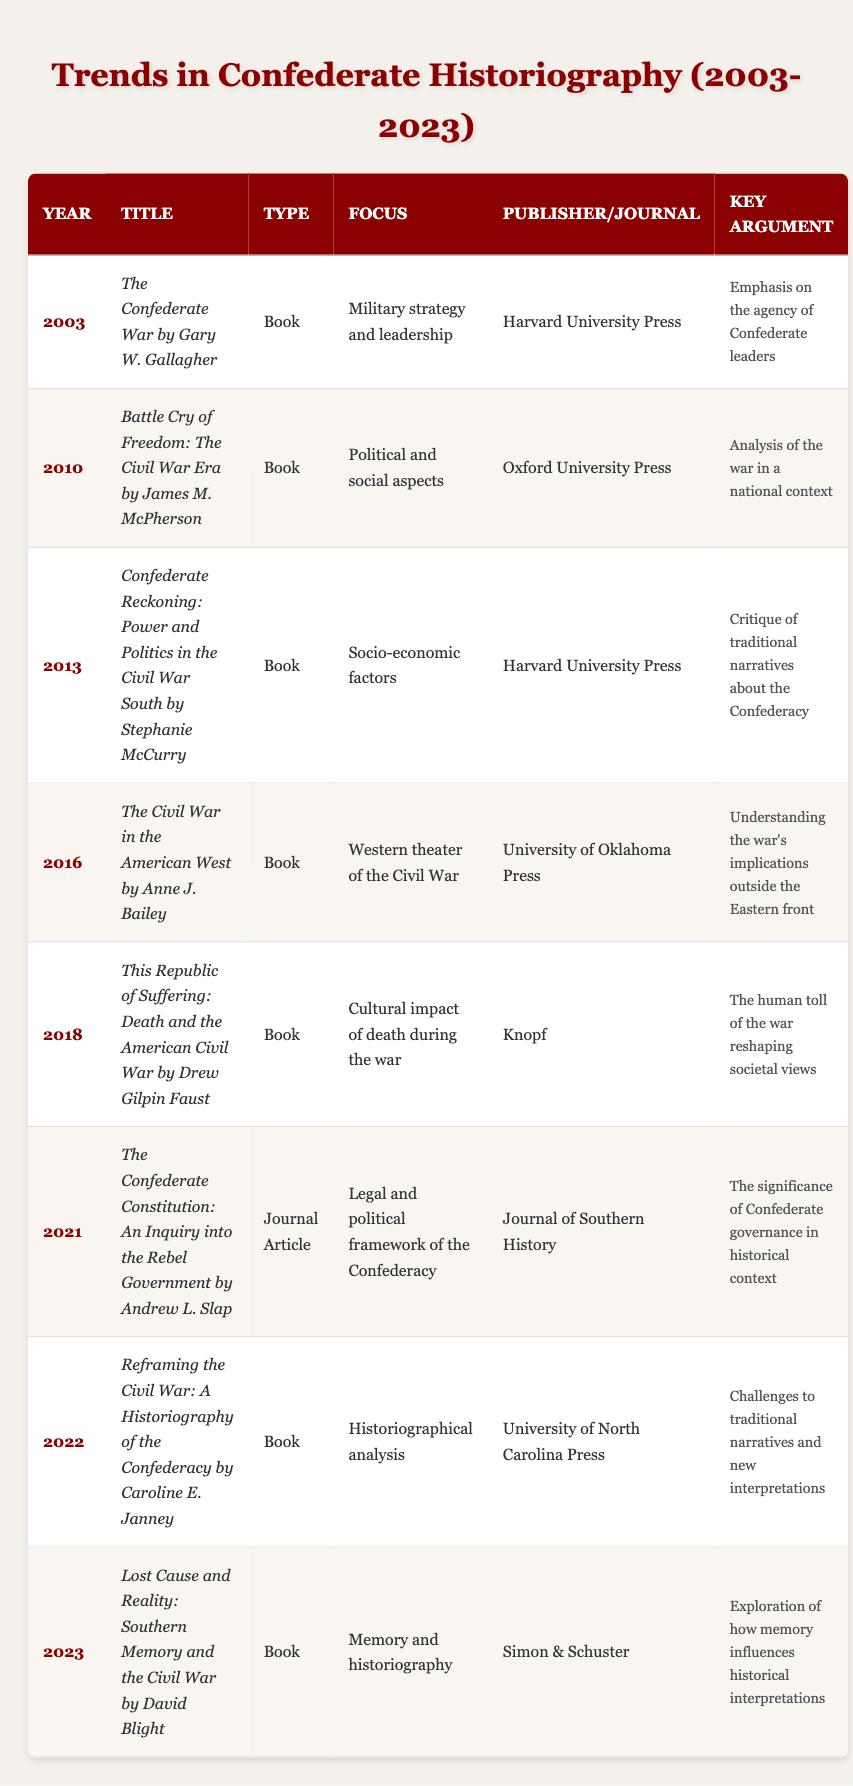What is the title of the book published in 2013? From the table, I can locate the row for the year 2013, which lists "Confederate Reckoning: Power and Politics in the Civil War South by Stephanie McCurry" under the Title column.
Answer: Confederate Reckoning: Power and Politics in the Civil War South by Stephanie McCurry Which publisher released the book "This Republic of Suffering"? By searching for the title "This Republic of Suffering" in the table, I find that it was published by Knopf.
Answer: Knopf How many books were published between 2010 and 2018? The table shows that there are six entries between the years 2010 and 2018 (including 2010 and 2018). Those years are 2010, 2013, 2016, and 2018.
Answer: 4 Did any works focus on the socio-economic factors of the Confederacy? In the table, the key argument for the entry from 2013 specifies that it critiques traditional narratives about the Confederacy with a focus on socio-economic factors. Therefore, the answer is yes.
Answer: Yes What is the key argument presented in the book published in 2023? The book published in 2023 is titled "Lost Cause and Reality: Southern Memory and the Civil War by David Blight," and it argues that it explores how memory influences historical interpretations.
Answer: Exploration of how memory influences historical interpretations What is the difference in publication years between the first and last works listed? The first work was published in 2003 and the last in 2023. To find the difference, subtract 2003 from 2023, which gives 20 years.
Answer: 20 Which work addresses the legal and political framework of the Confederacy? The table shows that "The Confederate Constitution: An Inquiry into the Rebel Government by Andrew L. Slap" published in 2021 focuses on the legal and political framework of the Confederacy.
Answer: The Confederate Constitution: An Inquiry into the Rebel Government by Andrew L. Slap How many of the listed works were published by Harvard University Press? From the table, I can see that there are three works published by Harvard University Press (2003, 2013).
Answer: 2 